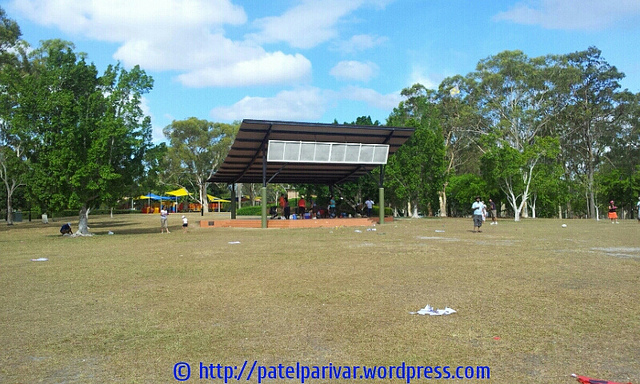<image>What is the color of water? There is no water in the image. However, the color of water can be blue, brown, or clear. What is the color of water? There is no water in the picture. 